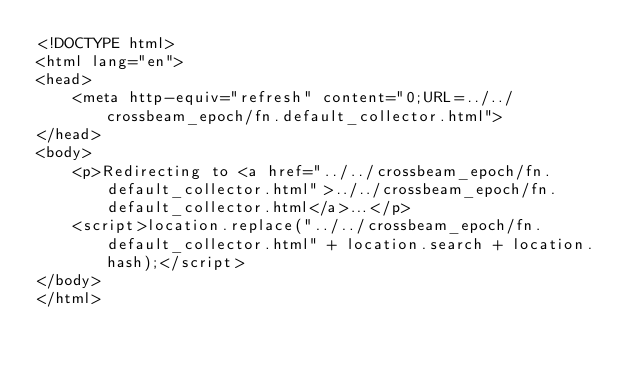<code> <loc_0><loc_0><loc_500><loc_500><_HTML_><!DOCTYPE html>
<html lang="en">
<head>
    <meta http-equiv="refresh" content="0;URL=../../crossbeam_epoch/fn.default_collector.html">
</head>
<body>
    <p>Redirecting to <a href="../../crossbeam_epoch/fn.default_collector.html">../../crossbeam_epoch/fn.default_collector.html</a>...</p>
    <script>location.replace("../../crossbeam_epoch/fn.default_collector.html" + location.search + location.hash);</script>
</body>
</html></code> 